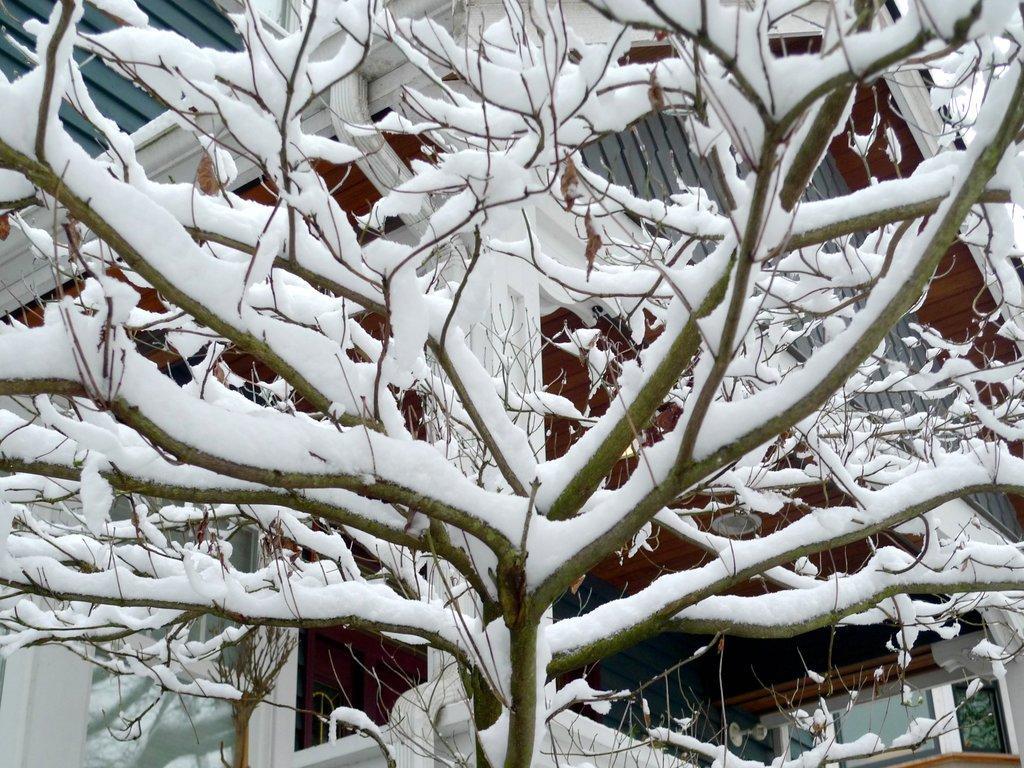Please provide a concise description of this image. In this image we can see some dried trees with snow, one object attached to the house and one house in the background. 